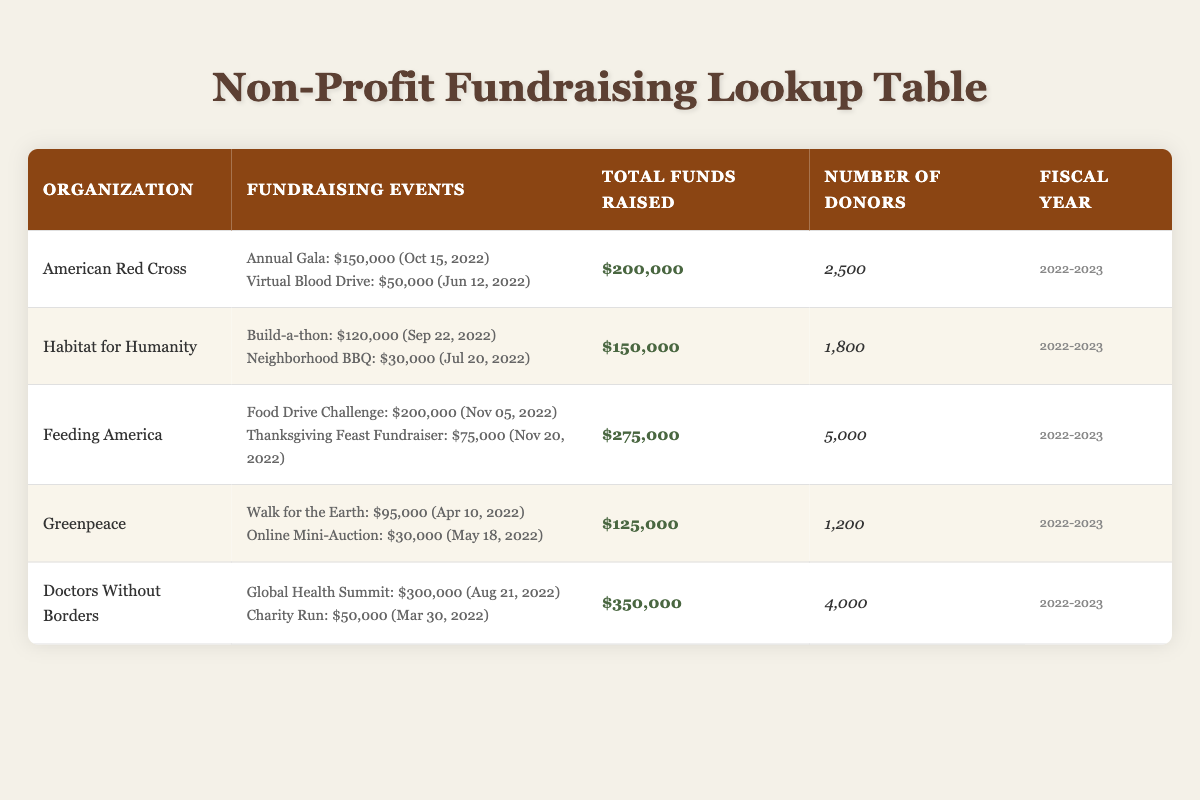What organization raised the most funds in the fiscal year 2022-2023? By scanning through the "Total Funds Raised" column, I can see that "Doctors Without Borders" has the highest total of $350,000 among all organizations listed.
Answer: Doctors Without Borders How much money did the American Red Cross raise from its fundraising events? The table shows that the American Red Cross raised a total of $200,000, which is specified in the "Total Funds Raised" column.
Answer: $200,000 Which organization had the least number of donors? Looking at the "Number of Donors" column, Greenpeace has the lowest count with 1,200 donors, which is less than any other organization in the table.
Answer: Greenpeace What is the average amount raised by Feeding America’s events? Feeding America had two fundraising events: a $200,000 Food Drive Challenge and a $75,000 Thanksgiving Feast Fundraiser. The total raised is $275,000, divided by 2 events gives an average amount raised of $275,000 / 2 = $137,500.
Answer: $137,500 Did Habitat for Humanity raise more than $160,000? The total funds raised by Habitat for Humanity is $150,000 as per the "Total Funds Raised" column, which is less than $160,000. Therefore, the answer is no.
Answer: No What was the total amount raised by all the organizations combined? By adding the total funds raised for each organization: $200,000 (American Red Cross) + $150,000 (Habitat for Humanity) + $275,000 (Feeding America) + $125,000 (Greenpeace) + $350,000 (Doctors Without Borders), the sum is $200,000 + $150,000 + $275,000 + $125,000 + $350,000 = $1,100,000.
Answer: $1,100,000 How many fundraising events did Greenpeace hold? The table lists two fundraising events for Greenpeace: "Walk for the Earth" and "Online Mini-Auction." This means they held a total of 2 events.
Answer: 2 Is the total amount raised by Feeding America greater than the total amount raised by Greenpeace? Feeding America raised $275,000 while Greenpeace raised $125,000. Since $275,000 is greater than $125,000, the answer is yes.
Answer: Yes What is the sum of total funds raised for American Red Cross and Habitat for Humanity? The total funds raised by American Red Cross is $200,000 and by Habitat for Humanity is $150,000. Adding these amounts together gives $200,000 + $150,000 = $350,000.
Answer: $350,000 